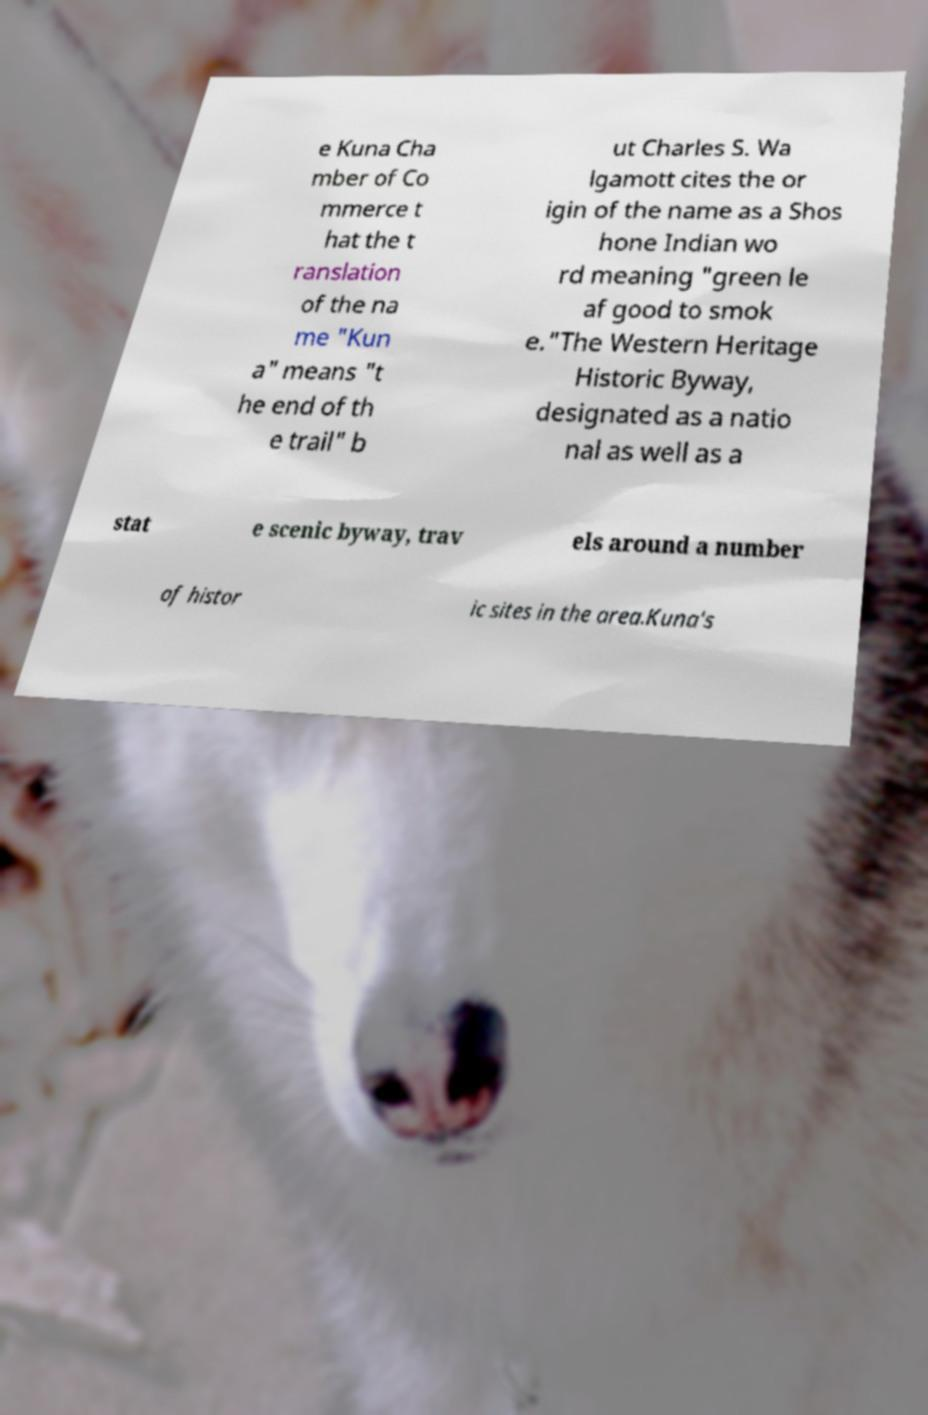Please identify and transcribe the text found in this image. e Kuna Cha mber of Co mmerce t hat the t ranslation of the na me "Kun a" means "t he end of th e trail" b ut Charles S. Wa lgamott cites the or igin of the name as a Shos hone Indian wo rd meaning "green le af good to smok e."The Western Heritage Historic Byway, designated as a natio nal as well as a stat e scenic byway, trav els around a number of histor ic sites in the area.Kuna's 